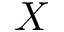<formula> <loc_0><loc_0><loc_500><loc_500>X</formula> 